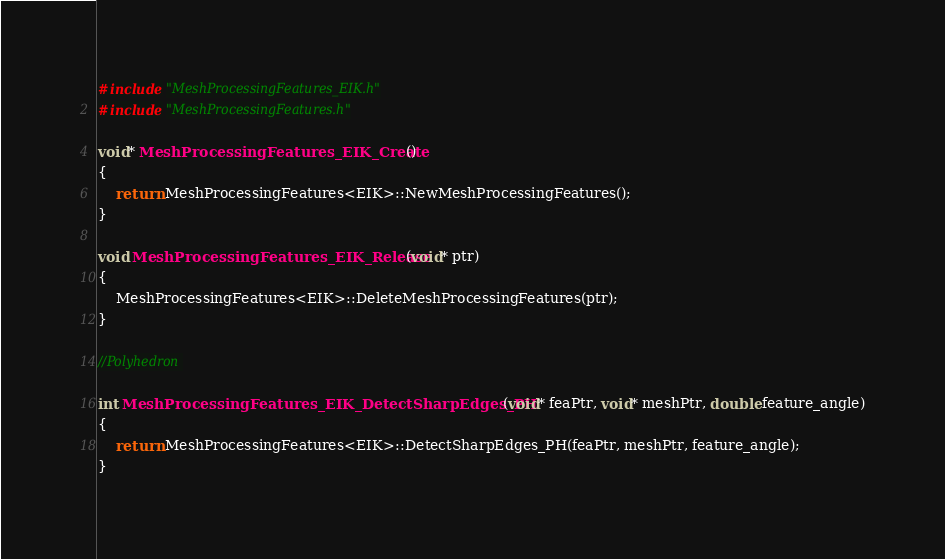<code> <loc_0><loc_0><loc_500><loc_500><_C++_>#include "MeshProcessingFeatures_EIK.h"
#include "MeshProcessingFeatures.h"

void* MeshProcessingFeatures_EIK_Create()
{
	return MeshProcessingFeatures<EIK>::NewMeshProcessingFeatures();
}

void MeshProcessingFeatures_EIK_Release(void* ptr)
{
	MeshProcessingFeatures<EIK>::DeleteMeshProcessingFeatures(ptr);
}

//Polyhedron 

int MeshProcessingFeatures_EIK_DetectSharpEdges_PH(void* feaPtr, void* meshPtr, double feature_angle)
{
	return MeshProcessingFeatures<EIK>::DetectSharpEdges_PH(feaPtr, meshPtr, feature_angle);
}
</code> 